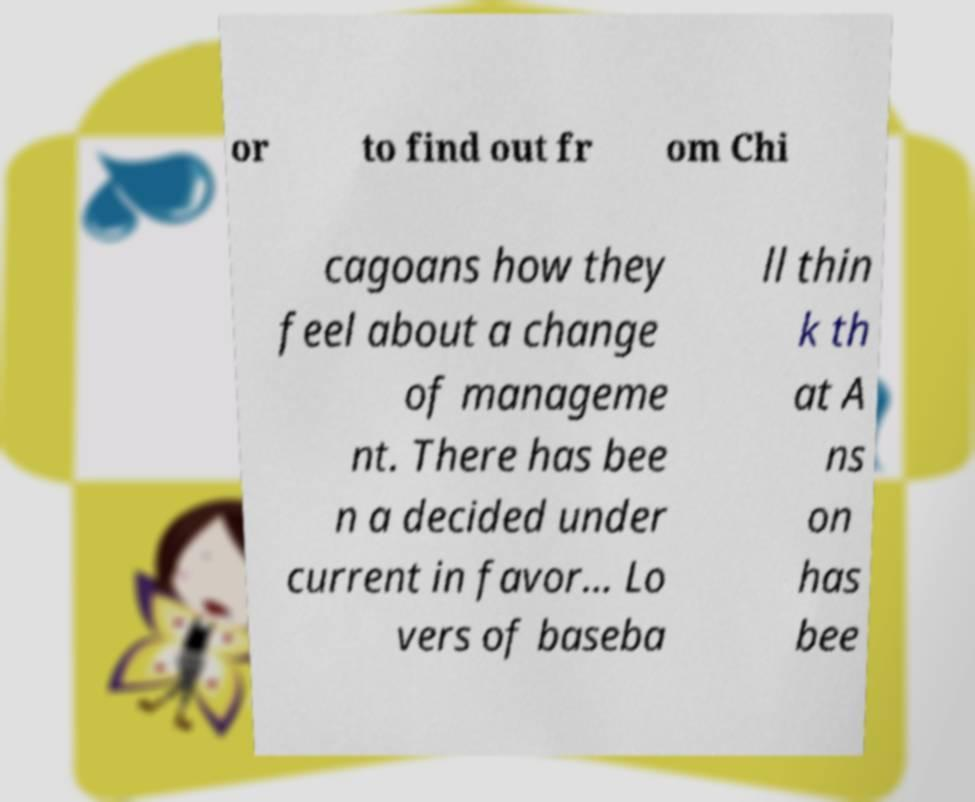For documentation purposes, I need the text within this image transcribed. Could you provide that? or to find out fr om Chi cagoans how they feel about a change of manageme nt. There has bee n a decided under current in favor... Lo vers of baseba ll thin k th at A ns on has bee 